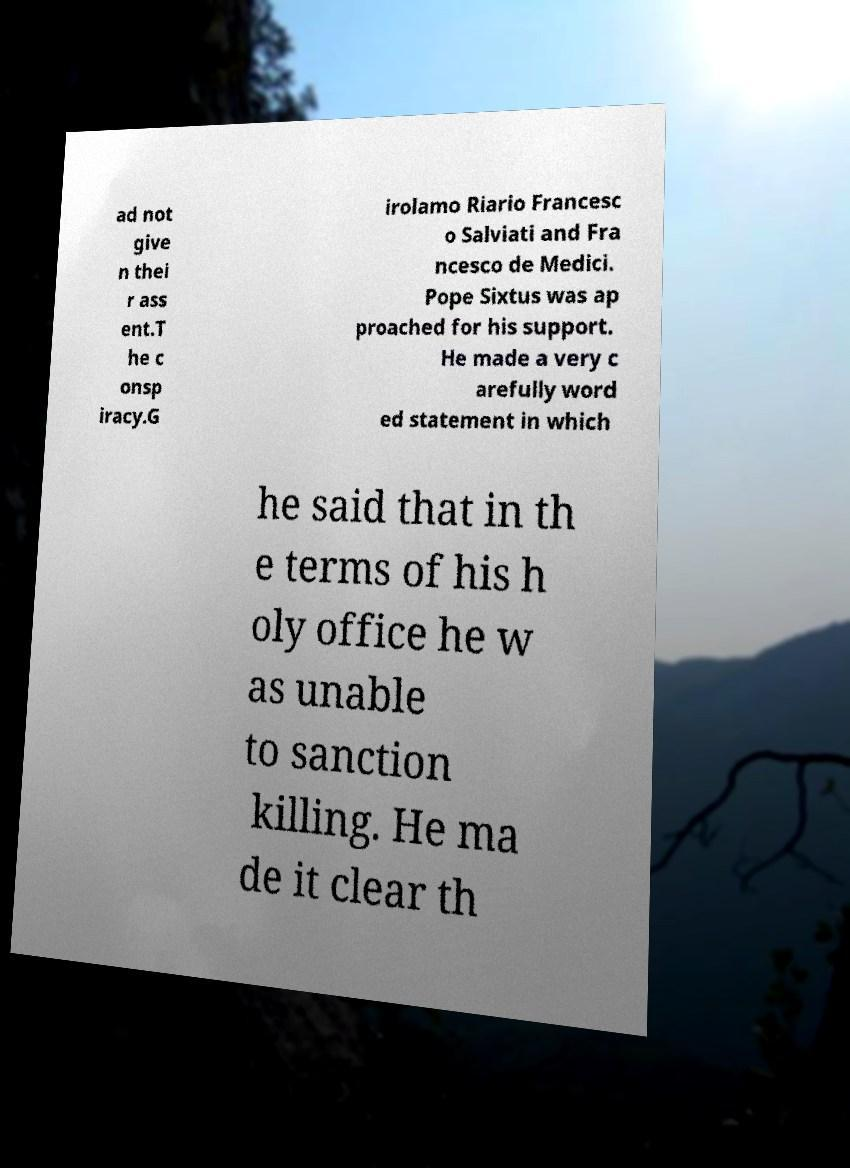Please identify and transcribe the text found in this image. ad not give n thei r ass ent.T he c onsp iracy.G irolamo Riario Francesc o Salviati and Fra ncesco de Medici. Pope Sixtus was ap proached for his support. He made a very c arefully word ed statement in which he said that in th e terms of his h oly office he w as unable to sanction killing. He ma de it clear th 